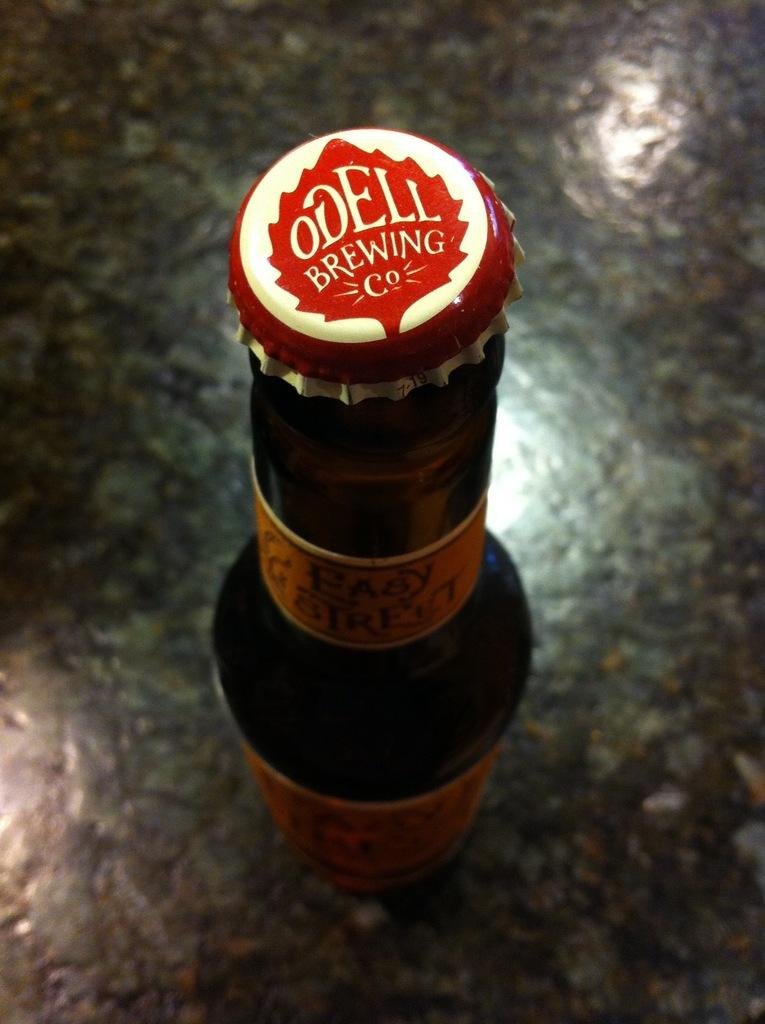<image>
Create a compact narrative representing the image presented. A bottle of beer which says ODELL BREWING Co on the bottle cap 